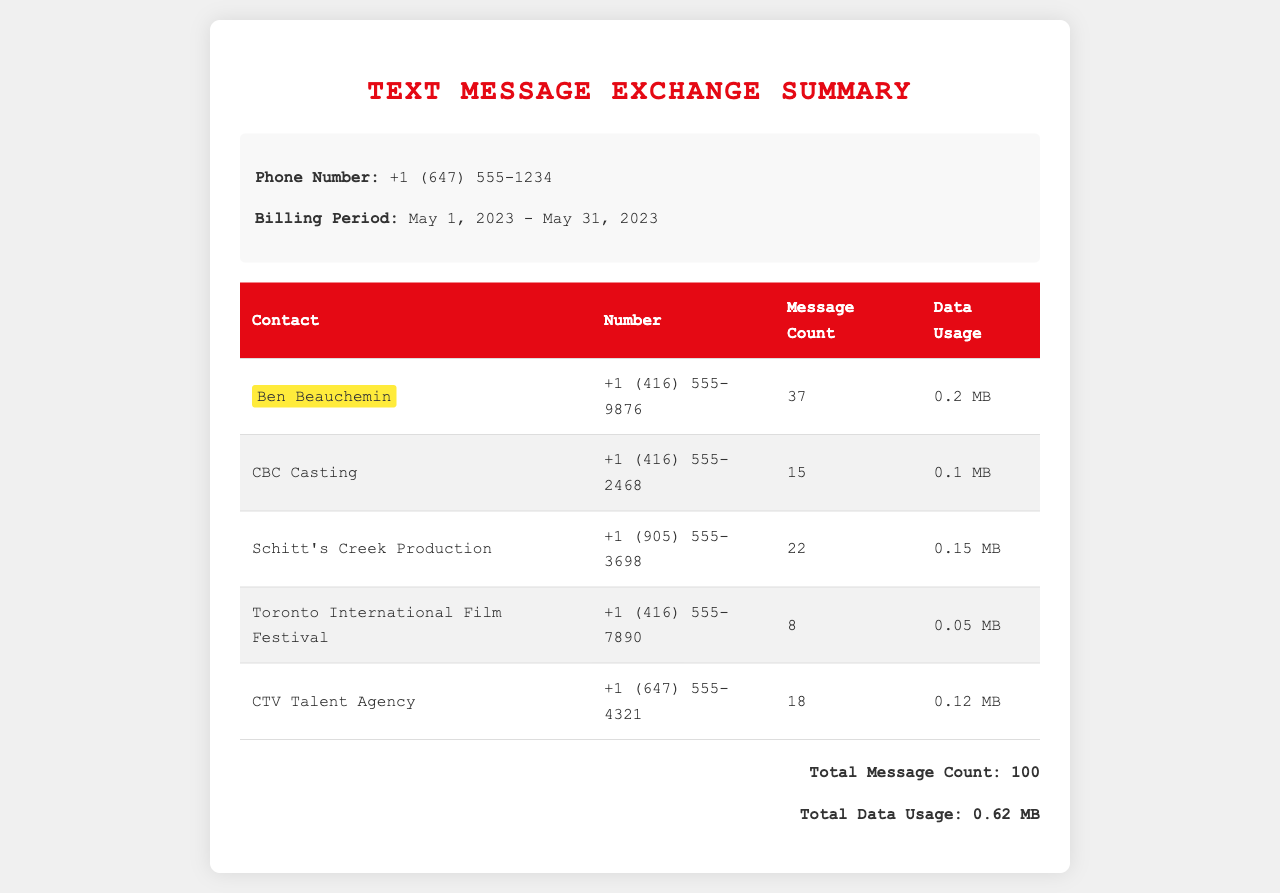what is the phone number of Ben Beauchemin? The phone number of Ben Beauchemin is listed in the document as +1 (416) 555-9876.
Answer: +1 (416) 555-9876 how many messages were exchanged with CBC Casting? The document states that 15 messages were exchanged with CBC Casting.
Answer: 15 what is the total data usage for all contacts? The total data usage for all contacts is provided as 0.62 MB in the document.
Answer: 0.62 MB which contact had the highest message count? Ben Beauchemin is the contact with the highest message count, which is 37.
Answer: 37 how many messages were exchanged with the Toronto International Film Festival? The document indicates that 8 messages were exchanged with the Toronto International Film Festival.
Answer: 8 what is the billing period for the text message exchanges? The billing period is documented as May 1, 2023 - May 31, 2023.
Answer: May 1, 2023 - May 31, 2023 which contact had the lowest data usage? The contact with the lowest data usage is Toronto International Film Festival with 0.05 MB.
Answer: 0.05 MB how many total contacts are listed in the document? The document lists a total of 5 contacts in the exchange summary.
Answer: 5 what is the data usage for the CTV Talent Agency? According to the document, the data usage for CTV Talent Agency is 0.12 MB.
Answer: 0.12 MB 